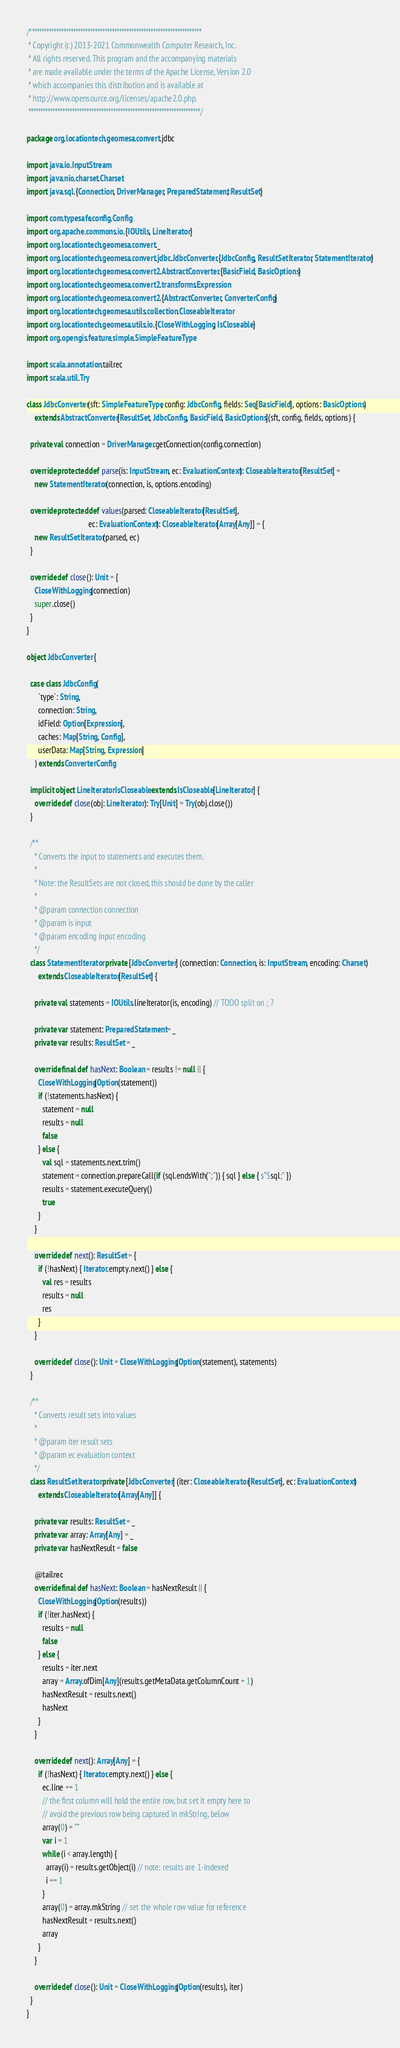Convert code to text. <code><loc_0><loc_0><loc_500><loc_500><_Scala_>/***********************************************************************
 * Copyright (c) 2013-2021 Commonwealth Computer Research, Inc.
 * All rights reserved. This program and the accompanying materials
 * are made available under the terms of the Apache License, Version 2.0
 * which accompanies this distribution and is available at
 * http://www.opensource.org/licenses/apache2.0.php.
 ***********************************************************************/

package org.locationtech.geomesa.convert.jdbc

import java.io.InputStream
import java.nio.charset.Charset
import java.sql.{Connection, DriverManager, PreparedStatement, ResultSet}

import com.typesafe.config.Config
import org.apache.commons.io.{IOUtils, LineIterator}
import org.locationtech.geomesa.convert._
import org.locationtech.geomesa.convert.jdbc.JdbcConverter.{JdbcConfig, ResultSetIterator, StatementIterator}
import org.locationtech.geomesa.convert2.AbstractConverter.{BasicField, BasicOptions}
import org.locationtech.geomesa.convert2.transforms.Expression
import org.locationtech.geomesa.convert2.{AbstractConverter, ConverterConfig}
import org.locationtech.geomesa.utils.collection.CloseableIterator
import org.locationtech.geomesa.utils.io.{CloseWithLogging, IsCloseable}
import org.opengis.feature.simple.SimpleFeatureType

import scala.annotation.tailrec
import scala.util.Try

class JdbcConverter(sft: SimpleFeatureType, config: JdbcConfig, fields: Seq[BasicField], options: BasicOptions)
    extends AbstractConverter[ResultSet, JdbcConfig, BasicField, BasicOptions](sft, config, fields, options) {

  private val connection = DriverManager.getConnection(config.connection)

  override protected def parse(is: InputStream, ec: EvaluationContext): CloseableIterator[ResultSet] =
    new StatementIterator(connection, is, options.encoding)

  override protected def values(parsed: CloseableIterator[ResultSet],
                                ec: EvaluationContext): CloseableIterator[Array[Any]] = {
    new ResultSetIterator(parsed, ec)
  }

  override def close(): Unit = {
    CloseWithLogging(connection)
    super.close()
  }
}

object JdbcConverter {

  case class JdbcConfig(
      `type`: String,
      connection: String,
      idField: Option[Expression],
      caches: Map[String, Config],
      userData: Map[String, Expression]
    ) extends ConverterConfig

  implicit object LineIteratorIsCloseable extends IsCloseable[LineIterator] {
    override def close(obj: LineIterator): Try[Unit] = Try(obj.close())
  }

  /**
    * Converts the input to statements and executes them.
    *
    * Note: the ResultSets are not closed, this should be done by the caller
    *
    * @param connection connection
    * @param is input
    * @param encoding input encoding
    */
  class StatementIterator private [JdbcConverter] (connection: Connection, is: InputStream, encoding: Charset)
      extends CloseableIterator[ResultSet] {

    private val statements = IOUtils.lineIterator(is, encoding) // TODO split on ; ?

    private var statement: PreparedStatement = _
    private var results: ResultSet = _

    override final def hasNext: Boolean = results != null || {
      CloseWithLogging(Option(statement))
      if (!statements.hasNext) {
        statement = null
        results = null
        false
      } else {
        val sql = statements.next.trim()
        statement = connection.prepareCall(if (sql.endsWith(";")) { sql } else { s"$sql;" })
        results = statement.executeQuery()
        true
      }
    }

    override def next(): ResultSet = {
      if (!hasNext) { Iterator.empty.next() } else {
        val res = results
        results = null
        res
      }
    }

    override def close(): Unit = CloseWithLogging(Option(statement), statements)
  }

  /**
    * Converts result sets into values
    *
    * @param iter result sets
    * @param ec evaluation context
    */
  class ResultSetIterator private [JdbcConverter] (iter: CloseableIterator[ResultSet], ec: EvaluationContext)
      extends CloseableIterator[Array[Any]] {

    private var results: ResultSet = _
    private var array: Array[Any] = _
    private var hasNextResult = false

    @tailrec
    override final def hasNext: Boolean = hasNextResult || {
      CloseWithLogging(Option(results))
      if (!iter.hasNext) {
        results = null
        false
      } else {
        results = iter.next
        array = Array.ofDim[Any](results.getMetaData.getColumnCount + 1)
        hasNextResult = results.next()
        hasNext
      }
    }

    override def next(): Array[Any] = {
      if (!hasNext) { Iterator.empty.next() } else {
        ec.line += 1
        // the first column will hold the entire row, but set it empty here to
        // avoid the previous row being captured in mkString, below
        array(0) = ""
        var i = 1
        while (i < array.length) {
          array(i) = results.getObject(i) // note: results are 1-indexed
          i += 1
        }
        array(0) = array.mkString // set the whole row value for reference
        hasNextResult = results.next()
        array
      }
    }

    override def close(): Unit = CloseWithLogging(Option(results), iter)
  }
}
</code> 